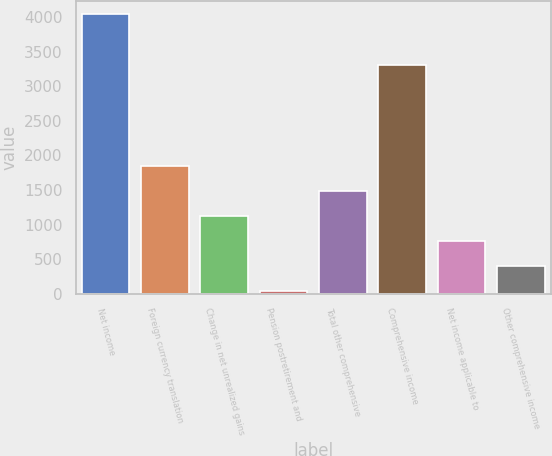<chart> <loc_0><loc_0><loc_500><loc_500><bar_chart><fcel>Net income<fcel>Foreign currency translation<fcel>Change in net unrealized gains<fcel>Pension postretirement and<fcel>Total other comprehensive<fcel>Comprehensive income<fcel>Net income applicable to<fcel>Other comprehensive income<nl><fcel>4038.8<fcel>1850<fcel>1123.2<fcel>33<fcel>1486.6<fcel>3312<fcel>759.8<fcel>396.4<nl></chart> 